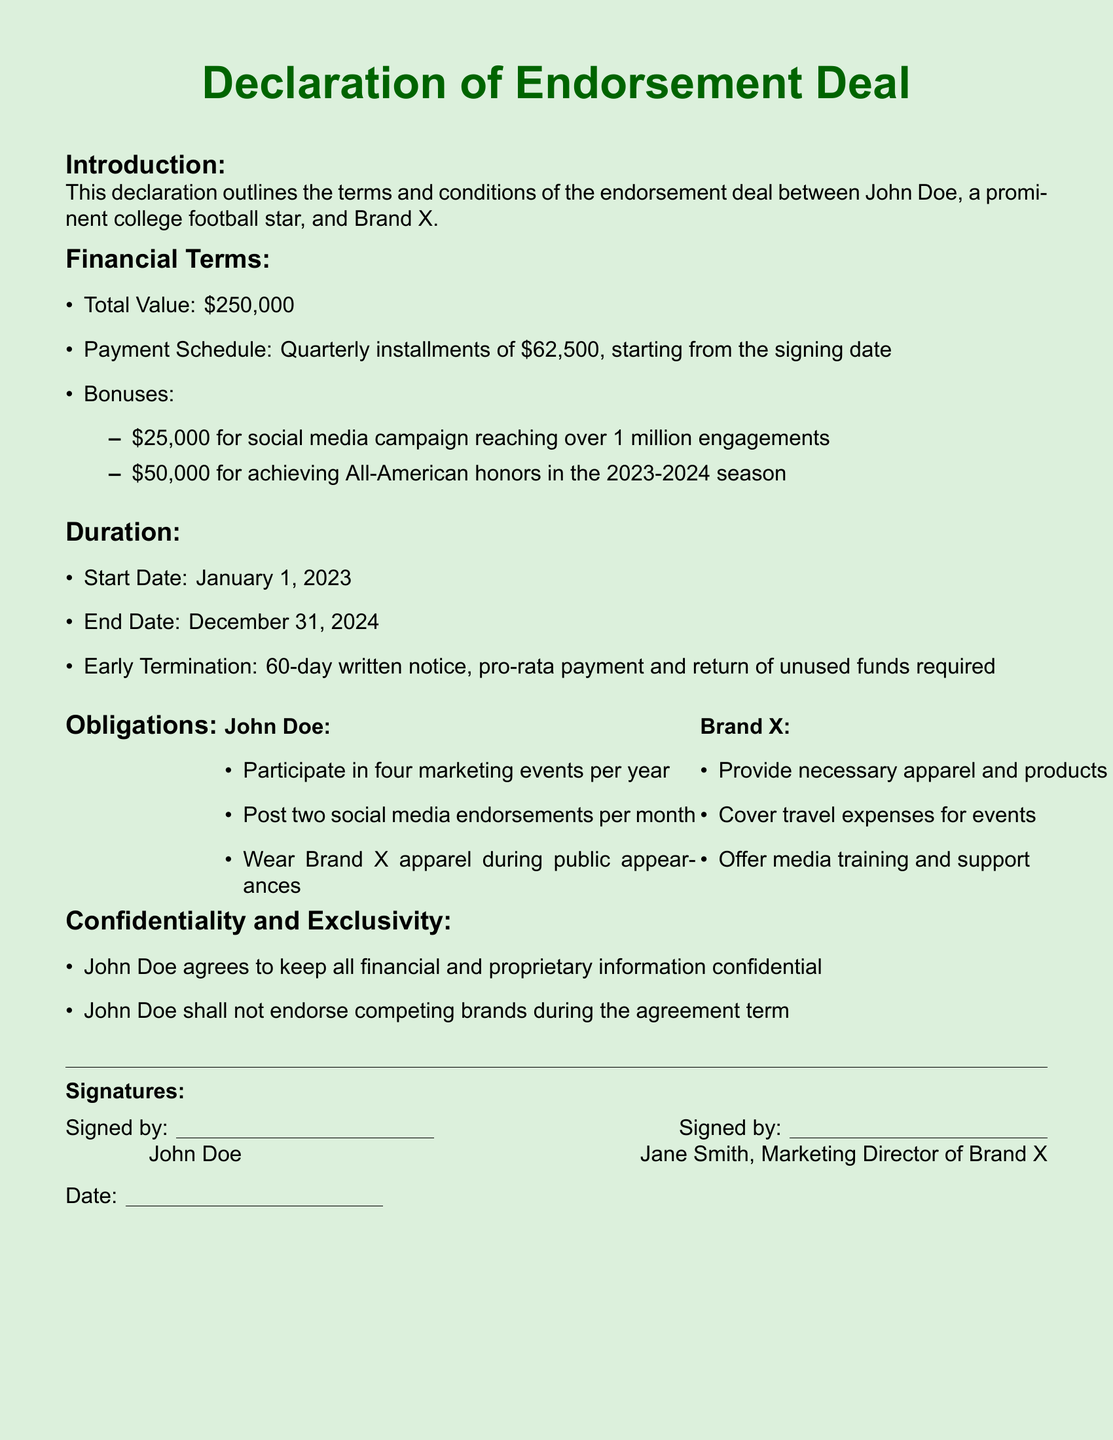What is the total value of the deal? The total value of the deal is stated in the financial terms section of the document.
Answer: $250,000 When does the endorsement deal start? The start date of the endorsement deal is specified in the duration section of the document.
Answer: January 1, 2023 How many marketing events must John Doe participate in per year? The obligations for John Doe detail the number of marketing events he must attend each year.
Answer: Four What is the bonus for achieving All-American honors? The bonus amount for achieving All-American honors is listed in the financial terms subsection about bonuses.
Answer: $50,000 What is required for early termination of the deal? The conditions for early termination of the agreement are outlined in the duration section.
Answer: 60-day written notice What apparel must John Doe wear during public appearances? The obligations for John Doe state what apparel he is required to wear.
Answer: Brand X apparel Who covers travel expenses for events? The obligations for Brand X specify who is responsible for travel expenses.
Answer: Brand X How many social media endorsements must John Doe post each month? The obligations for John Doe include the frequency of social media endorsements he must post.
Answer: Two What must John Doe maintain confidentiality about? The confidentiality terms in the document explain what John Doe must keep confidential.
Answer: Financial and proprietary information 